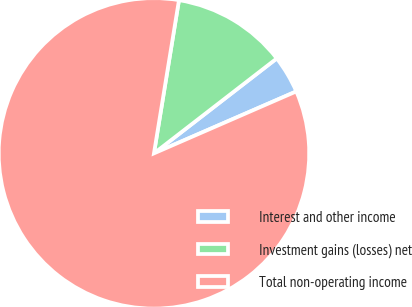<chart> <loc_0><loc_0><loc_500><loc_500><pie_chart><fcel>Interest and other income<fcel>Investment gains (losses) net<fcel>Total non-operating income<nl><fcel>3.94%<fcel>11.95%<fcel>84.11%<nl></chart> 